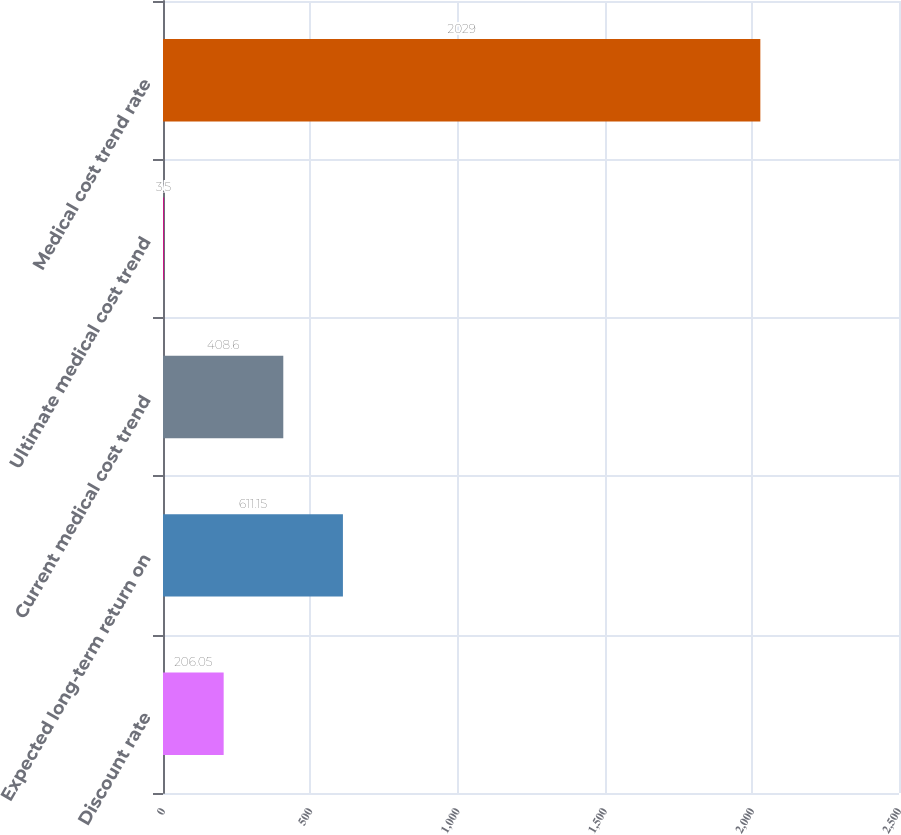<chart> <loc_0><loc_0><loc_500><loc_500><bar_chart><fcel>Discount rate<fcel>Expected long-term return on<fcel>Current medical cost trend<fcel>Ultimate medical cost trend<fcel>Medical cost trend rate<nl><fcel>206.05<fcel>611.15<fcel>408.6<fcel>3.5<fcel>2029<nl></chart> 